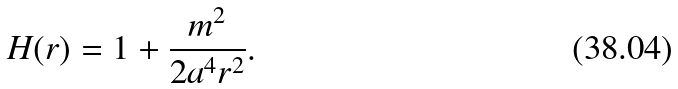Convert formula to latex. <formula><loc_0><loc_0><loc_500><loc_500>H ( r ) = 1 + \frac { m ^ { 2 } } { 2 a ^ { 4 } r ^ { 2 } } .</formula> 